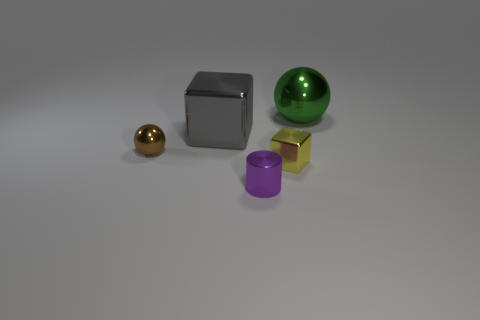Is the size of the purple cylinder the same as the gray shiny thing?
Your answer should be very brief. No. How many metallic things are either large yellow cylinders or balls?
Your answer should be compact. 2. There is a green thing that is the same size as the gray object; what material is it?
Ensure brevity in your answer.  Metal. How many other things are made of the same material as the cylinder?
Your response must be concise. 4. Are there fewer gray shiny cubes right of the green shiny thing than purple shiny cylinders?
Make the answer very short. Yes. Is the shape of the yellow object the same as the gray metallic object?
Your answer should be compact. Yes. What size is the green metal thing behind the big gray metallic thing that is behind the block that is in front of the brown ball?
Your response must be concise. Large. There is a sphere that is behind the shiny sphere that is left of the gray block; what is its size?
Provide a succinct answer. Large. What color is the shiny cylinder?
Ensure brevity in your answer.  Purple. There is a small thing that is in front of the small yellow metal thing; what number of tiny metal balls are right of it?
Provide a short and direct response. 0. 